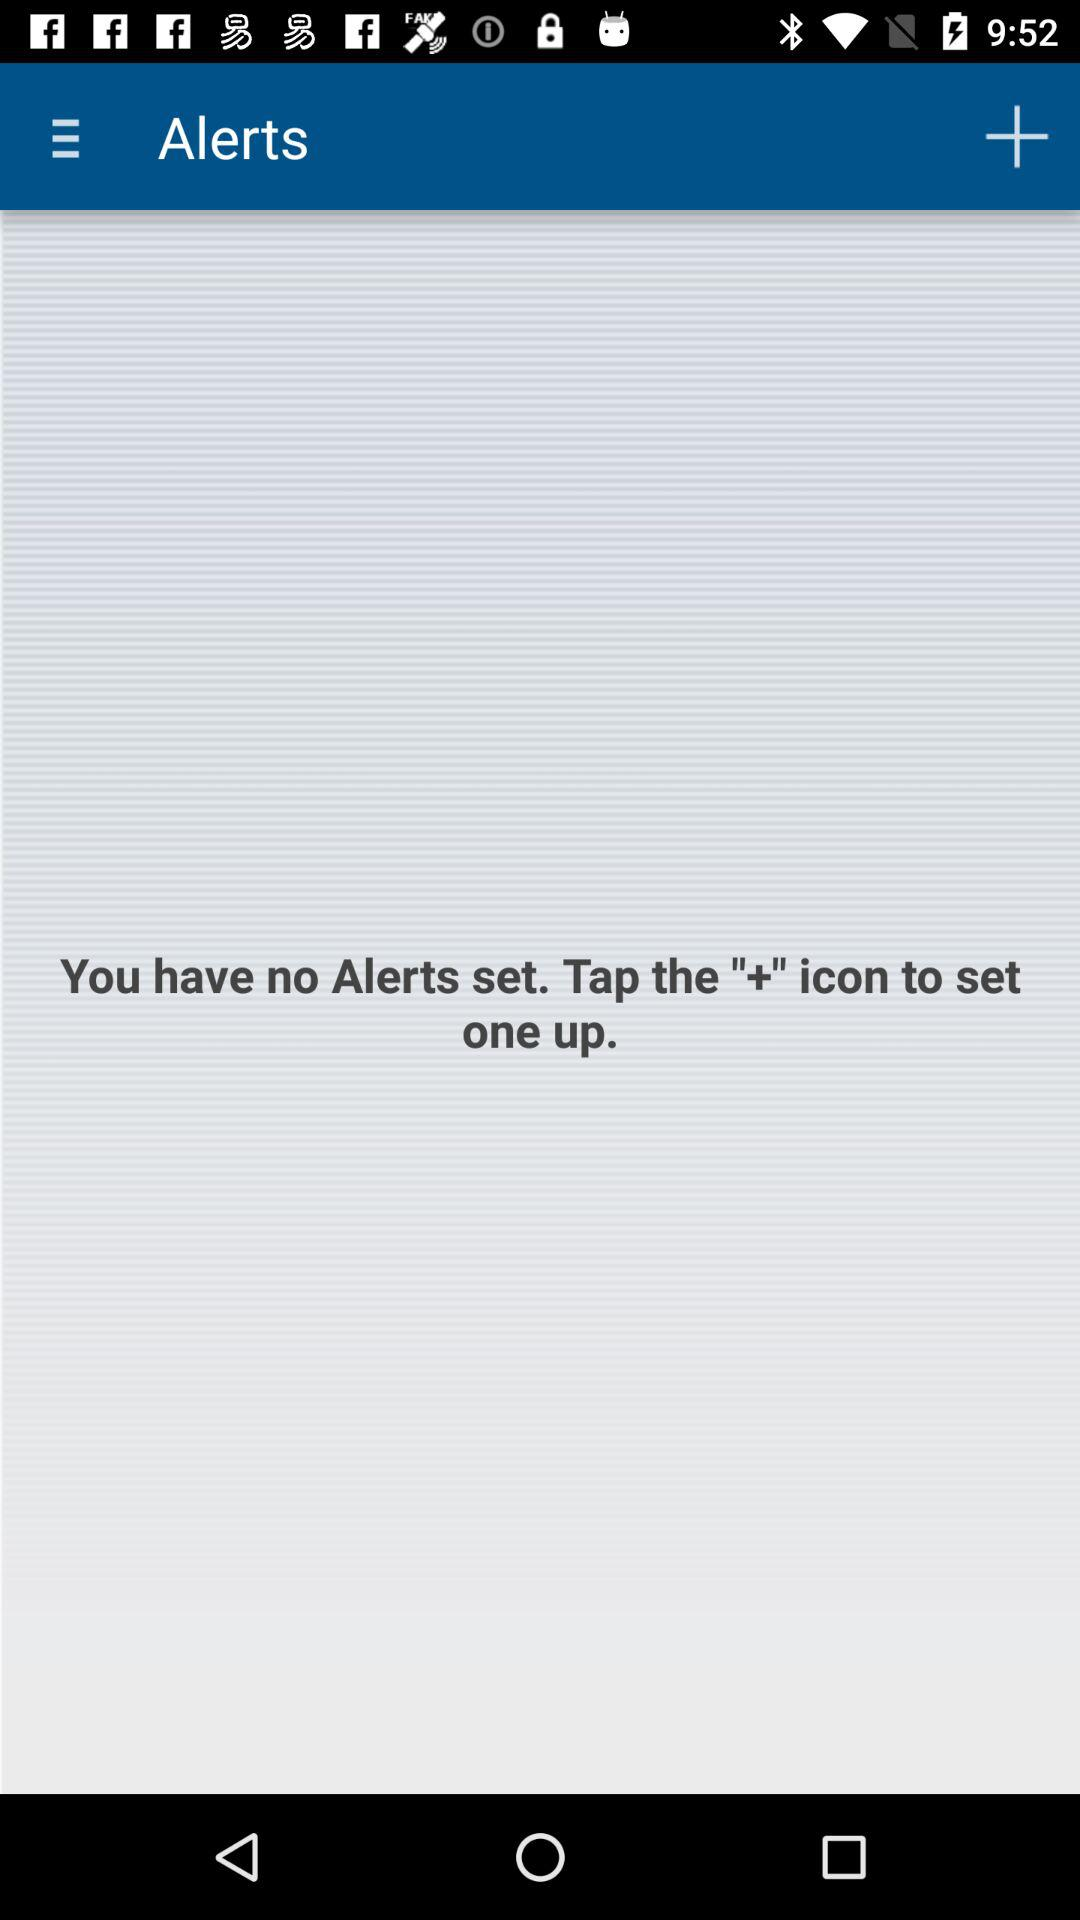How many alerts are currently set?
Answer the question using a single word or phrase. 0 